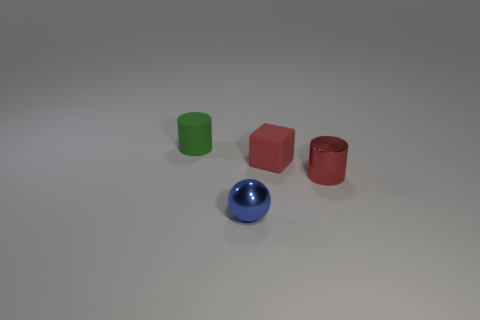Add 4 metal things. How many objects exist? 8 Subtract all spheres. How many objects are left? 3 Subtract all red cylinders. How many cylinders are left? 1 Subtract 0 yellow cylinders. How many objects are left? 4 Subtract all gray cylinders. Subtract all red balls. How many cylinders are left? 2 Subtract all red rubber things. Subtract all purple cylinders. How many objects are left? 3 Add 4 metal cylinders. How many metal cylinders are left? 5 Add 3 cyan objects. How many cyan objects exist? 3 